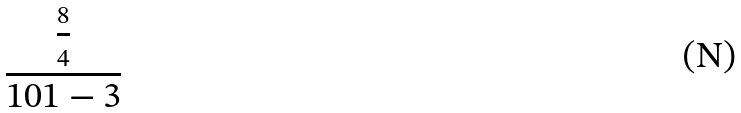Convert formula to latex. <formula><loc_0><loc_0><loc_500><loc_500>\frac { \frac { 8 } { 4 } } { 1 0 1 - 3 }</formula> 